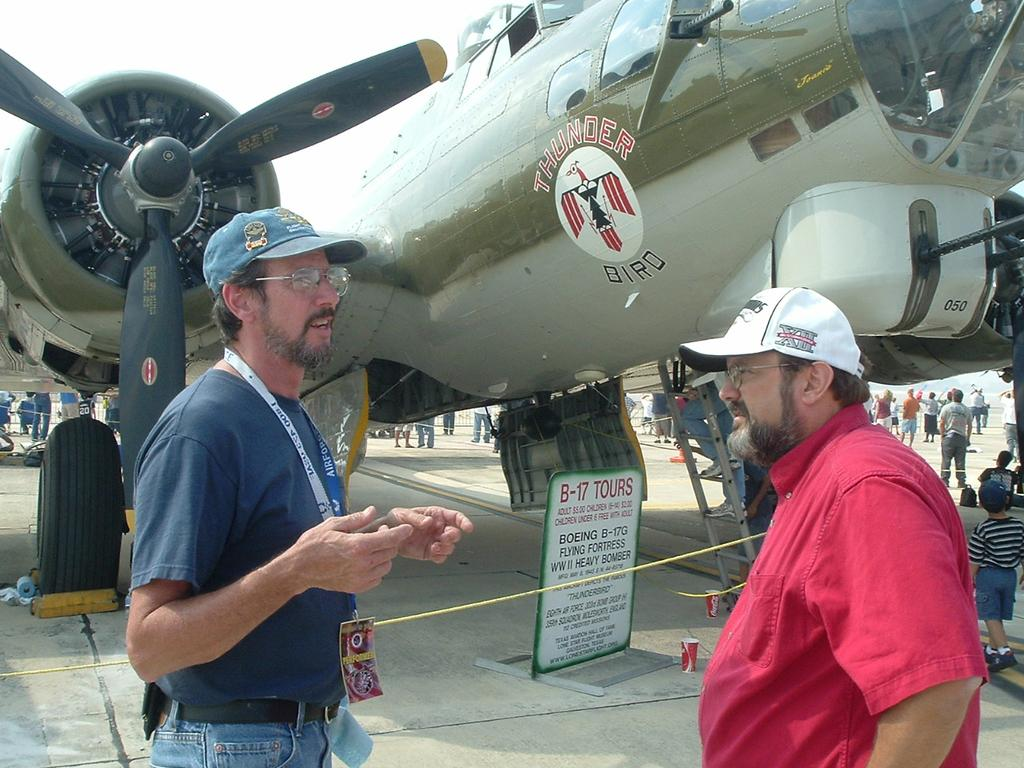<image>
Create a compact narrative representing the image presented. Two men standing in front of an airplane with the thunder birds logo on its side. 